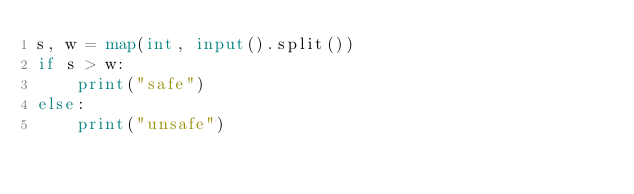Convert code to text. <code><loc_0><loc_0><loc_500><loc_500><_Python_>s, w = map(int, input().split())
if s > w:
    print("safe")
else:
    print("unsafe")</code> 